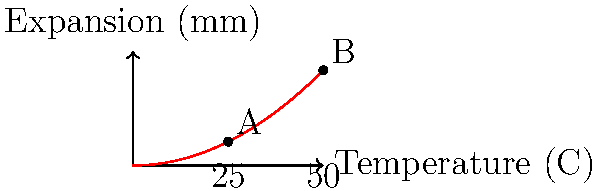A large outdoor sculpture made of aluminum is installed in a city park. The sculpture expands as temperature increases, following the curve shown in the graph. If the temperature rises from 25°C to 50°C, by how much does the sculpture's length increase? Let's approach this step-by-step:

1) The graph shows the relationship between temperature and expansion.

2) We need to find the difference in expansion between 25°C (point A) and 50°C (point B).

3) The x-axis represents temperature, where:
   - 5 units = 25°C
   - 10 units = 50°C

4) From the graph:
   - At 25°C (point A), the expansion is approximately 1.25 mm
   - At 50°C (point B), the expansion is approximately 5 mm

5) To calculate the increase in length:
   $$\text{Increase} = \text{Expansion at 50°C} - \text{Expansion at 25°C}$$
   $$\text{Increase} = 5 \text{ mm} - 1.25 \text{ mm} = 3.75 \text{ mm}$$

6) Therefore, as the temperature rises from 25°C to 50°C, the sculpture's length increases by 3.75 mm.
Answer: 3.75 mm 